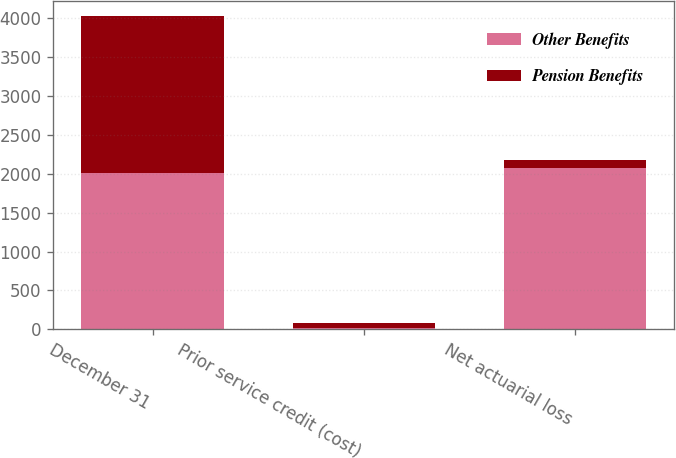Convert chart. <chart><loc_0><loc_0><loc_500><loc_500><stacked_bar_chart><ecel><fcel>December 31<fcel>Prior service credit (cost)<fcel>Net actuarial loss<nl><fcel>Other Benefits<fcel>2011<fcel>14<fcel>2069<nl><fcel>Pension Benefits<fcel>2011<fcel>73<fcel>107<nl></chart> 